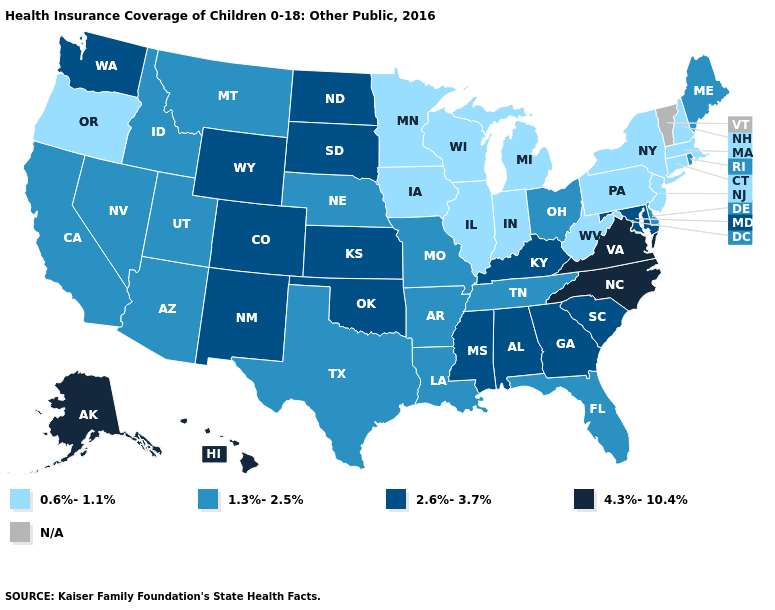Among the states that border Illinois , which have the lowest value?
Answer briefly. Indiana, Iowa, Wisconsin. What is the value of Washington?
Short answer required. 2.6%-3.7%. What is the value of West Virginia?
Quick response, please. 0.6%-1.1%. Does the first symbol in the legend represent the smallest category?
Answer briefly. Yes. Does North Carolina have the highest value in the USA?
Answer briefly. Yes. Name the states that have a value in the range 1.3%-2.5%?
Short answer required. Arizona, Arkansas, California, Delaware, Florida, Idaho, Louisiana, Maine, Missouri, Montana, Nebraska, Nevada, Ohio, Rhode Island, Tennessee, Texas, Utah. Name the states that have a value in the range 4.3%-10.4%?
Be succinct. Alaska, Hawaii, North Carolina, Virginia. What is the value of Idaho?
Concise answer only. 1.3%-2.5%. What is the highest value in the Northeast ?
Short answer required. 1.3%-2.5%. Does the map have missing data?
Answer briefly. Yes. Name the states that have a value in the range 2.6%-3.7%?
Concise answer only. Alabama, Colorado, Georgia, Kansas, Kentucky, Maryland, Mississippi, New Mexico, North Dakota, Oklahoma, South Carolina, South Dakota, Washington, Wyoming. Name the states that have a value in the range 2.6%-3.7%?
Quick response, please. Alabama, Colorado, Georgia, Kansas, Kentucky, Maryland, Mississippi, New Mexico, North Dakota, Oklahoma, South Carolina, South Dakota, Washington, Wyoming. 